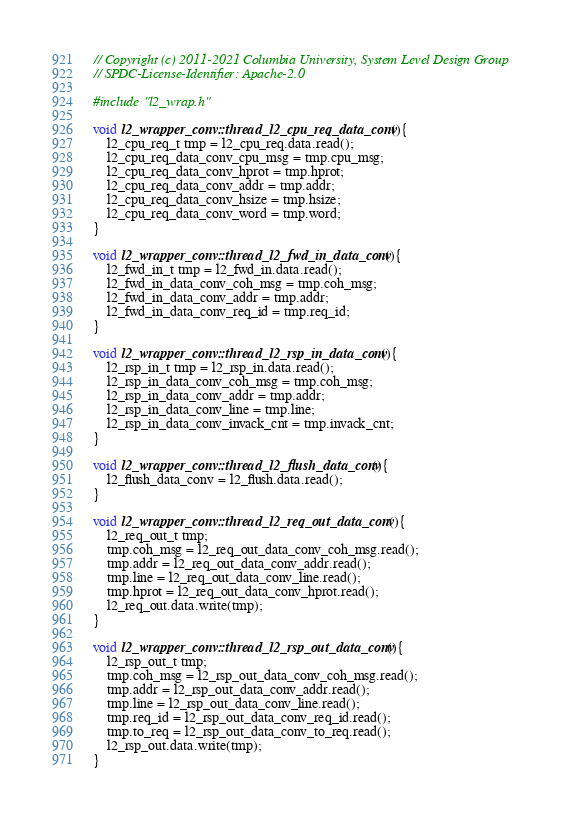<code> <loc_0><loc_0><loc_500><loc_500><_C++_>// Copyright (c) 2011-2021 Columbia University, System Level Design Group
// SPDC-License-Identifier: Apache-2.0

#include "l2_wrap.h"

void l2_wrapper_conv::thread_l2_cpu_req_data_conv(){
    l2_cpu_req_t tmp = l2_cpu_req.data.read();
    l2_cpu_req_data_conv_cpu_msg = tmp.cpu_msg;
    l2_cpu_req_data_conv_hprot = tmp.hprot;
    l2_cpu_req_data_conv_addr = tmp.addr;
    l2_cpu_req_data_conv_hsize = tmp.hsize;
    l2_cpu_req_data_conv_word = tmp.word;
}

void l2_wrapper_conv::thread_l2_fwd_in_data_conv(){
    l2_fwd_in_t tmp = l2_fwd_in.data.read();
    l2_fwd_in_data_conv_coh_msg = tmp.coh_msg;
    l2_fwd_in_data_conv_addr = tmp.addr;
    l2_fwd_in_data_conv_req_id = tmp.req_id;
}

void l2_wrapper_conv::thread_l2_rsp_in_data_conv(){
    l2_rsp_in_t tmp = l2_rsp_in.data.read();
    l2_rsp_in_data_conv_coh_msg = tmp.coh_msg;
    l2_rsp_in_data_conv_addr = tmp.addr;
    l2_rsp_in_data_conv_line = tmp.line;
    l2_rsp_in_data_conv_invack_cnt = tmp.invack_cnt;
}

void l2_wrapper_conv::thread_l2_flush_data_conv(){
    l2_flush_data_conv = l2_flush.data.read();
}

void l2_wrapper_conv::thread_l2_req_out_data_conv(){
    l2_req_out_t tmp;
    tmp.coh_msg = l2_req_out_data_conv_coh_msg.read();
    tmp.addr = l2_req_out_data_conv_addr.read();
    tmp.line = l2_req_out_data_conv_line.read();
    tmp.hprot = l2_req_out_data_conv_hprot.read();
    l2_req_out.data.write(tmp);
}

void l2_wrapper_conv::thread_l2_rsp_out_data_conv(){
    l2_rsp_out_t tmp;
    tmp.coh_msg = l2_rsp_out_data_conv_coh_msg.read();
    tmp.addr = l2_rsp_out_data_conv_addr.read();
    tmp.line = l2_rsp_out_data_conv_line.read();
    tmp.req_id = l2_rsp_out_data_conv_req_id.read();
    tmp.to_req = l2_rsp_out_data_conv_to_req.read();
    l2_rsp_out.data.write(tmp);
}
</code> 